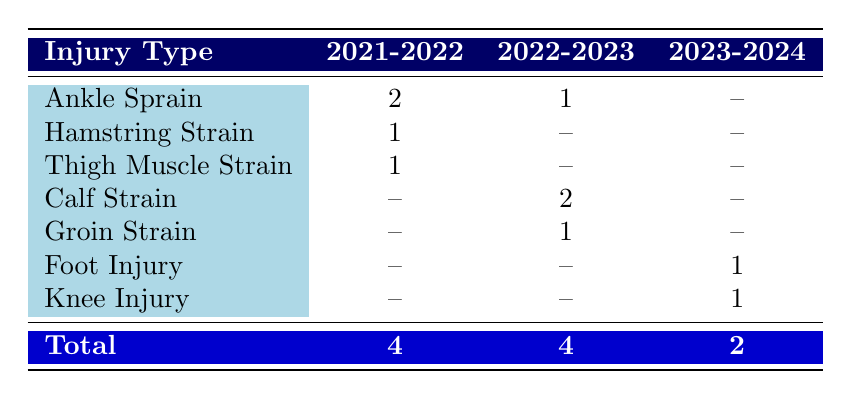What is the total number of injuries sustained by Jack Grealish in the 2021-2022 season? The table shows that in the 2021-2022 season, there are three injury types (Ankle Sprain, Hamstring Strain, Thigh Muscle Strain) with frequencies of 2, 1, and 1 respectively. To find the total, we add these frequencies: 2 + 1 + 1 = 4.
Answer: 4 How many different types of injuries did Jack Grealish sustain in the 2022-2023 season? In the 2022-2023 season, there are three injury types listed (Calf Strain, Groin Strain, Ankle Sprain). Thus, there are a total of 3 different types of injuries.
Answer: 3 Did Jack Grealish sustain more injuries in the 2021-2022 season than in the 2023-2024 season? The total number of injuries in the 2021-2022 season is 4, and in the 2023-2024 season, it is 2. Since 4 is greater than 2, the answer is yes.
Answer: Yes What is the difference in the frequency of Calf Strain injuries between the 2022-2023 and 2023-2024 seasons? The table indicates that the frequency of Calf Strain is 2 in the 2022-2023 season and there are no records for Calf Strain in the 2023-2024 season, thus the difference is 2 - 0 = 2.
Answer: 2 In which season did Jack Grealish sustain the highest number of total injuries? The total injuries for each season are as follows: 2021-2022: 4, 2022-2023: 4, and 2023-2024: 2. Both 2021-2022 and 2022-2023 have the highest number at 4. Therefore, the highest number of total injuries occurred in both the 2021-2022 and 2022-2023 seasons.
Answer: 2021-2022 and 2022-2023 What is the combined frequency of Foot Injury and Knee Injury in the 2023-2024 season? The table shows that in the 2023-2024 season, Foot Injury has a frequency of 1 and Knee Injury also has a frequency of 1. Therefore, the combined frequency is 1 + 1 = 2.
Answer: 2 Is it true that Jack Grealish had a Hamstring Strain injury in the 2022-2023 season? The table does not show any records of Hamstring Strain injuries in the 2022-2023 season, so the answer is false.
Answer: False What is the average number of injuries sustained by Jack Grealish across all seasons listed in the table? The total number of injuries across all seasons is calculated as follows: 4 (2021-2022) + 4 (2022-2023) + 2 (2023-2024) = 10. There are 3 seasons, therefore the average is 10 / 3 ≈ 3.33.
Answer: Approximately 3.33 